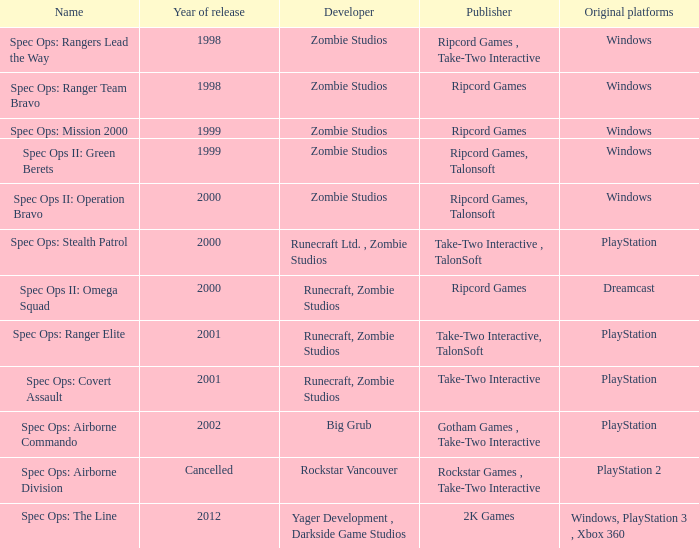Which publisher has release year of 2000 and an original dreamcast platform? Ripcord Games. 